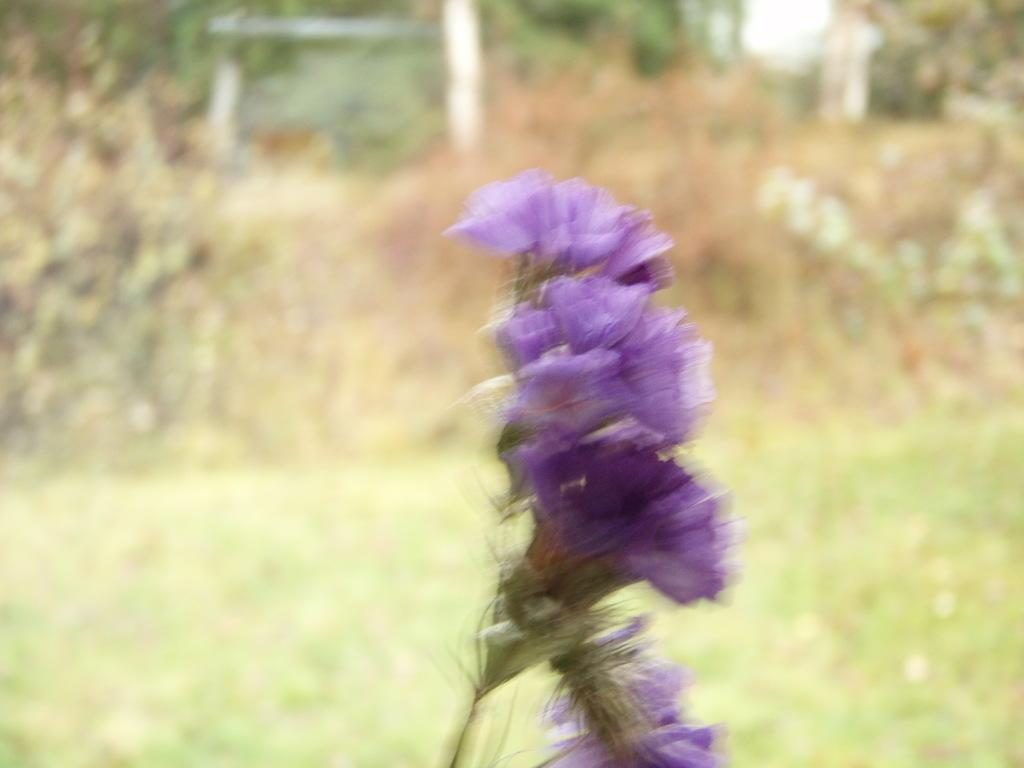What type of flower is in the image? There is a blue color Lily flower in the image. Can you describe the background of the image? The background of the image is blurred. What type of ghost can be seen interacting with the Lily flower in the image? There is no ghost present in the image; it features a blue color Lily flower with a blurred background. What type of basin is visible in the image? There is no basin present in the image. 